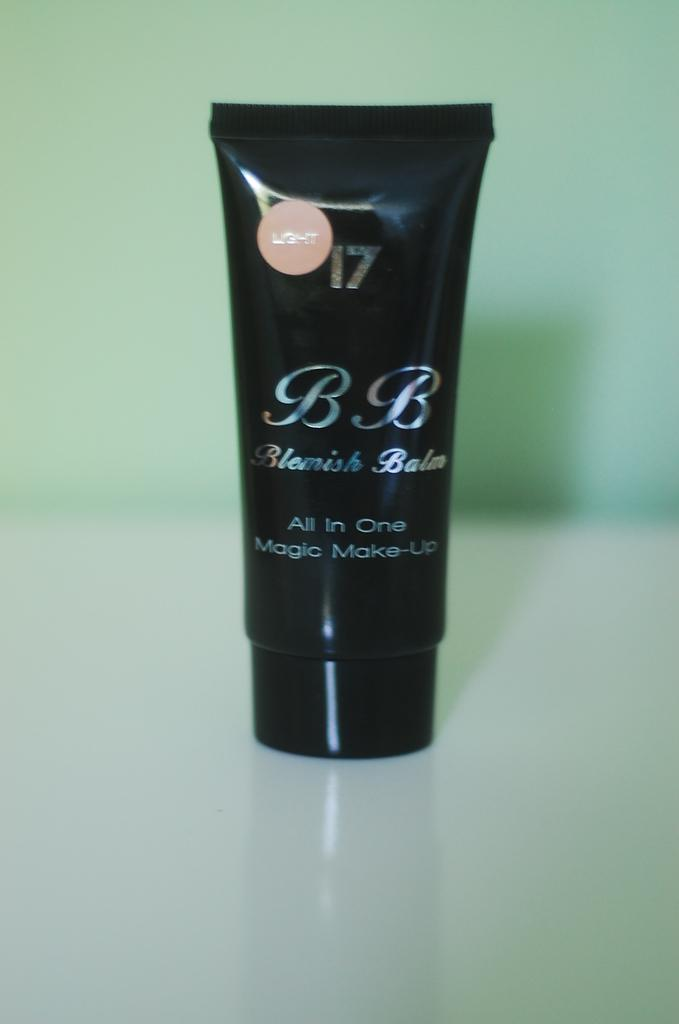Provide a one-sentence caption for the provided image. A black makeup bottle with the words Blemish Balm under the letters B.B. 